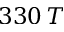<formula> <loc_0><loc_0><loc_500><loc_500>3 3 0 \, T</formula> 